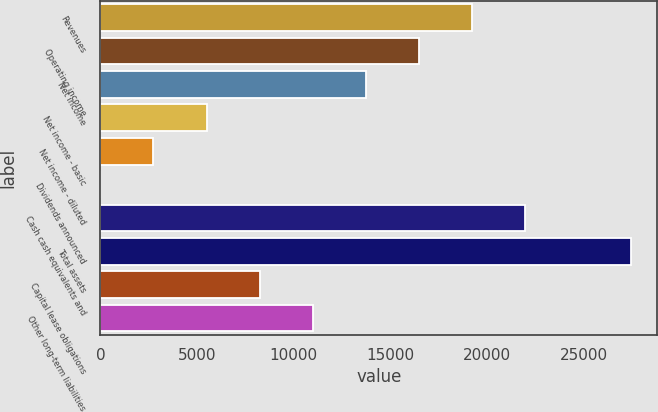<chart> <loc_0><loc_0><loc_500><loc_500><bar_chart><fcel>Revenues<fcel>Operating income<fcel>Net income<fcel>Net income - basic<fcel>Net income - diluted<fcel>Dividends announced<fcel>Cash cash equivalents and<fcel>Total assets<fcel>Capital lease obligations<fcel>Other long-term liabilities<nl><fcel>19211.7<fcel>16467.2<fcel>13722.8<fcel>5489.52<fcel>2745.09<fcel>0.66<fcel>21956.1<fcel>27445<fcel>8233.95<fcel>10978.4<nl></chart> 